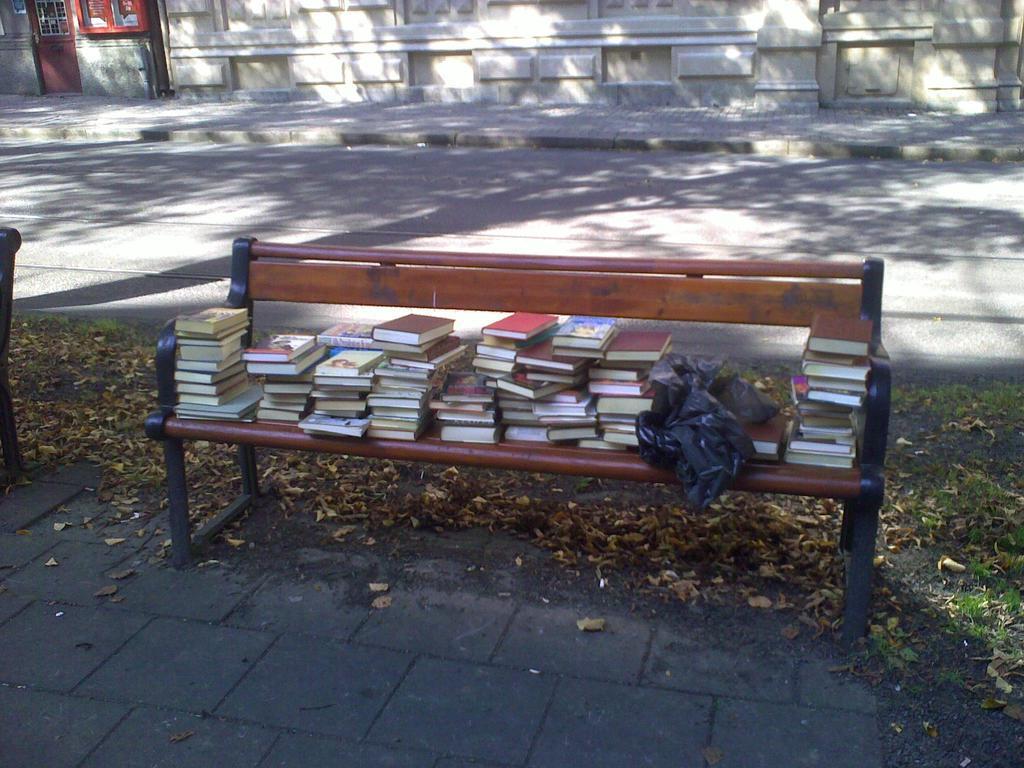Please provide a concise description of this image. In this image there is a bench, there are books on the bench, there is an object on the bench, there is an object truncated towards the left of the image, there is the road truncated, at the background of the image there is the wall truncated, there is an object truncated towards the top of the image, there is door truncated towards the top of the image, there are dried leaves on the ground, there is grass truncated towards the right of the image, there is the ground truncated towards the bottom of the image. 